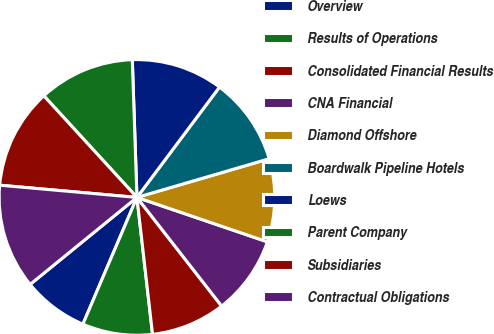<chart> <loc_0><loc_0><loc_500><loc_500><pie_chart><fcel>Overview<fcel>Results of Operations<fcel>Consolidated Financial Results<fcel>CNA Financial<fcel>Diamond Offshore<fcel>Boardwalk Pipeline Hotels<fcel>Loews<fcel>Parent Company<fcel>Subsidiaries<fcel>Contractual Obligations<nl><fcel>7.71%<fcel>8.22%<fcel>8.73%<fcel>9.24%<fcel>9.75%<fcel>10.25%<fcel>10.76%<fcel>11.27%<fcel>11.78%<fcel>12.29%<nl></chart> 